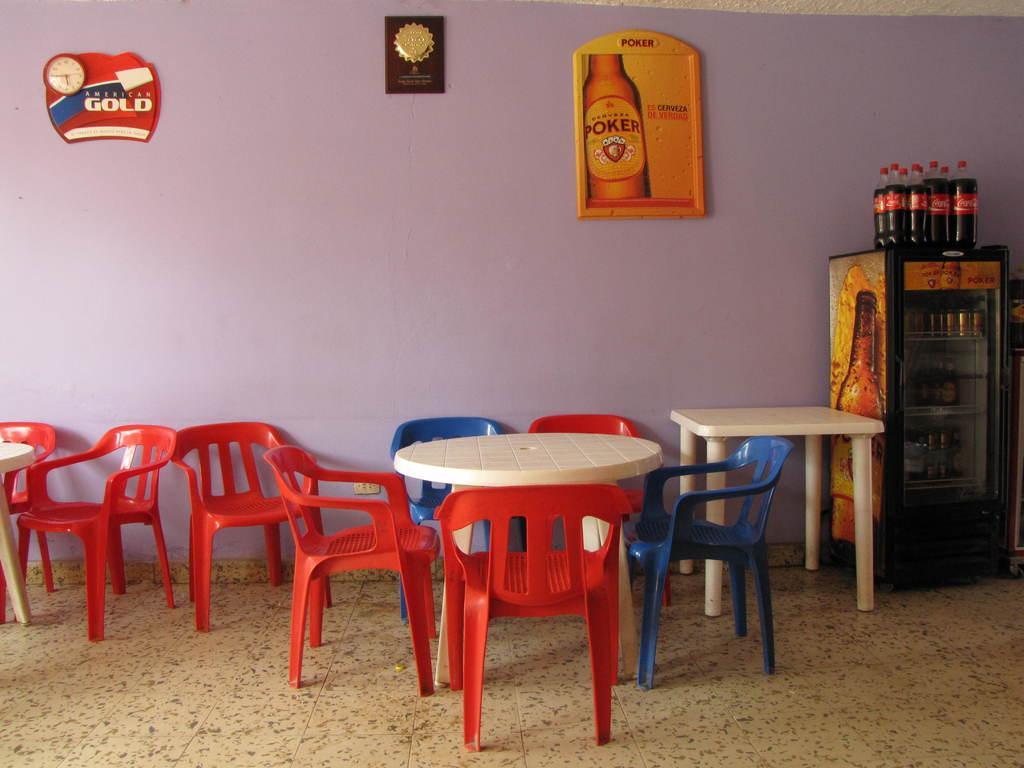Can you describe this image briefly? In this image I can see number of chairs and few tables. On the right side I can see a refrigerator and in it I can see number of things. I can also see few bottles on the top of it and in the background I can see few things and a clock on the wall. 